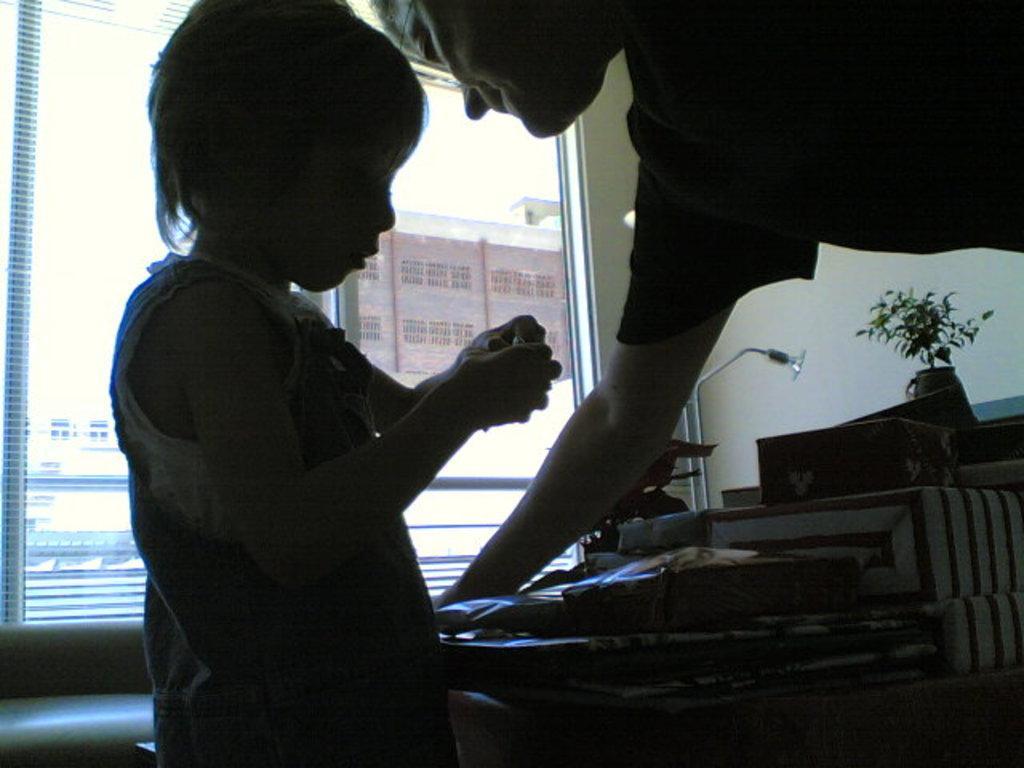Please provide a concise description of this image. In this picture we can see a person and a kid in the front, on the left side there is a glass, on the right side there is a plant, a light and some boxes, in the background there is a wall, we can see some papers pasted on the glass. 